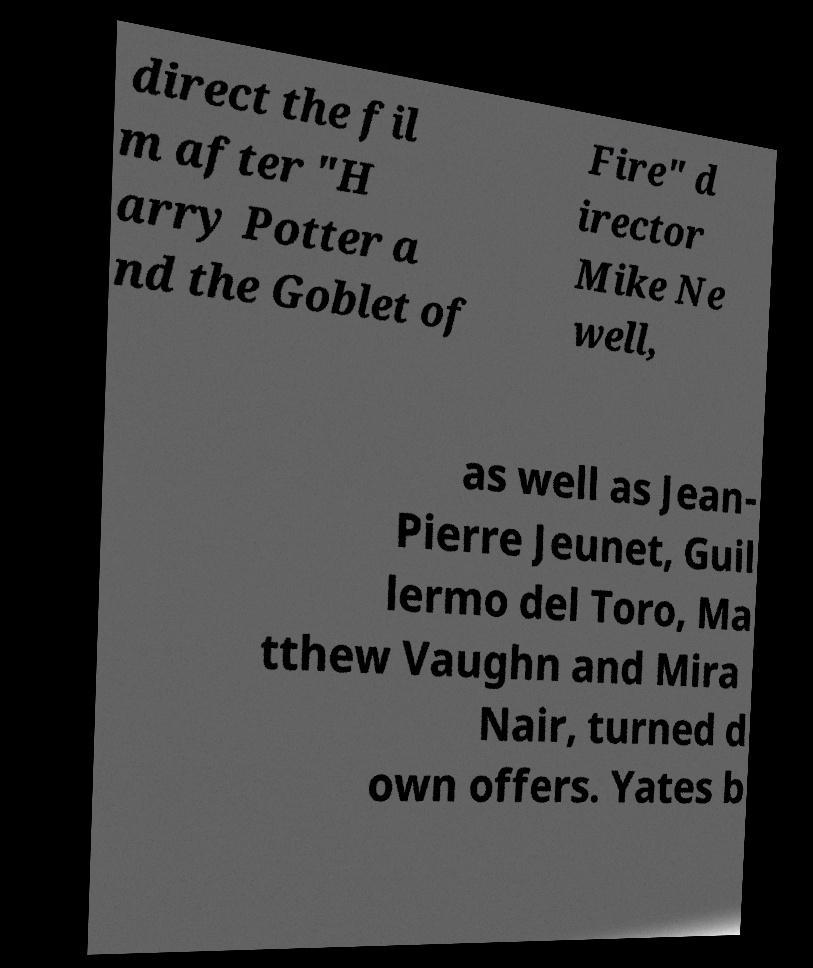For documentation purposes, I need the text within this image transcribed. Could you provide that? direct the fil m after "H arry Potter a nd the Goblet of Fire" d irector Mike Ne well, as well as Jean- Pierre Jeunet, Guil lermo del Toro, Ma tthew Vaughn and Mira Nair, turned d own offers. Yates b 